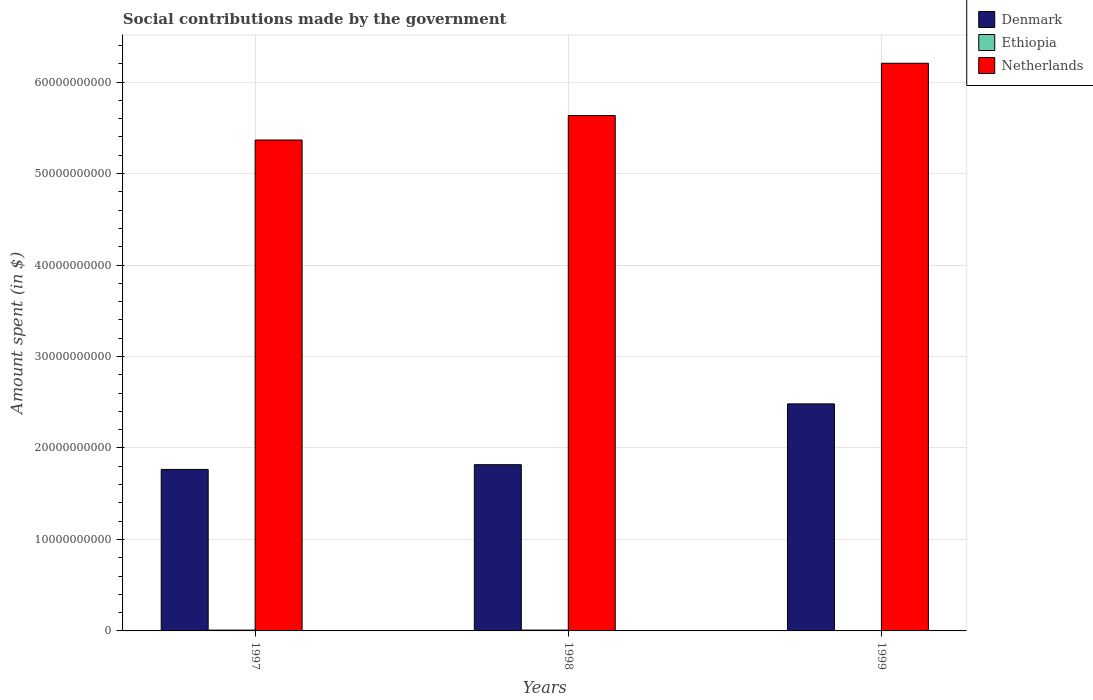How many different coloured bars are there?
Ensure brevity in your answer.  3. How many groups of bars are there?
Your answer should be very brief. 3. Are the number of bars per tick equal to the number of legend labels?
Your answer should be very brief. Yes. How many bars are there on the 1st tick from the right?
Your response must be concise. 3. In how many cases, is the number of bars for a given year not equal to the number of legend labels?
Offer a terse response. 0. What is the amount spent on social contributions in Denmark in 1999?
Provide a short and direct response. 2.48e+1. Across all years, what is the maximum amount spent on social contributions in Denmark?
Provide a short and direct response. 2.48e+1. Across all years, what is the minimum amount spent on social contributions in Ethiopia?
Offer a very short reply. 2.00e+05. In which year was the amount spent on social contributions in Ethiopia maximum?
Provide a short and direct response. 1998. In which year was the amount spent on social contributions in Netherlands minimum?
Provide a short and direct response. 1997. What is the total amount spent on social contributions in Ethiopia in the graph?
Give a very brief answer. 1.80e+08. What is the difference between the amount spent on social contributions in Ethiopia in 1997 and that in 1998?
Offer a terse response. -3.90e+06. What is the difference between the amount spent on social contributions in Ethiopia in 1998 and the amount spent on social contributions in Denmark in 1997?
Your response must be concise. -1.76e+1. What is the average amount spent on social contributions in Denmark per year?
Make the answer very short. 2.02e+1. In the year 1997, what is the difference between the amount spent on social contributions in Ethiopia and amount spent on social contributions in Denmark?
Offer a terse response. -1.76e+1. What is the ratio of the amount spent on social contributions in Ethiopia in 1998 to that in 1999?
Provide a short and direct response. 460.5. What is the difference between the highest and the second highest amount spent on social contributions in Ethiopia?
Offer a very short reply. 3.90e+06. What is the difference between the highest and the lowest amount spent on social contributions in Ethiopia?
Make the answer very short. 9.19e+07. Is the sum of the amount spent on social contributions in Denmark in 1997 and 1999 greater than the maximum amount spent on social contributions in Netherlands across all years?
Keep it short and to the point. No. What does the 2nd bar from the left in 1999 represents?
Your response must be concise. Ethiopia. Is it the case that in every year, the sum of the amount spent on social contributions in Denmark and amount spent on social contributions in Ethiopia is greater than the amount spent on social contributions in Netherlands?
Offer a terse response. No. How many bars are there?
Offer a terse response. 9. Are all the bars in the graph horizontal?
Keep it short and to the point. No. How many years are there in the graph?
Provide a succinct answer. 3. What is the difference between two consecutive major ticks on the Y-axis?
Ensure brevity in your answer.  1.00e+1. Does the graph contain any zero values?
Keep it short and to the point. No. Where does the legend appear in the graph?
Your response must be concise. Top right. How are the legend labels stacked?
Your answer should be compact. Vertical. What is the title of the graph?
Ensure brevity in your answer.  Social contributions made by the government. What is the label or title of the X-axis?
Provide a succinct answer. Years. What is the label or title of the Y-axis?
Provide a succinct answer. Amount spent (in $). What is the Amount spent (in $) in Denmark in 1997?
Provide a succinct answer. 1.77e+1. What is the Amount spent (in $) of Ethiopia in 1997?
Make the answer very short. 8.82e+07. What is the Amount spent (in $) in Netherlands in 1997?
Your answer should be very brief. 5.37e+1. What is the Amount spent (in $) of Denmark in 1998?
Offer a terse response. 1.82e+1. What is the Amount spent (in $) of Ethiopia in 1998?
Your response must be concise. 9.21e+07. What is the Amount spent (in $) of Netherlands in 1998?
Offer a terse response. 5.63e+1. What is the Amount spent (in $) of Denmark in 1999?
Your response must be concise. 2.48e+1. What is the Amount spent (in $) in Netherlands in 1999?
Keep it short and to the point. 6.21e+1. Across all years, what is the maximum Amount spent (in $) in Denmark?
Your response must be concise. 2.48e+1. Across all years, what is the maximum Amount spent (in $) in Ethiopia?
Your answer should be compact. 9.21e+07. Across all years, what is the maximum Amount spent (in $) in Netherlands?
Your response must be concise. 6.21e+1. Across all years, what is the minimum Amount spent (in $) of Denmark?
Your answer should be compact. 1.77e+1. Across all years, what is the minimum Amount spent (in $) of Netherlands?
Offer a terse response. 5.37e+1. What is the total Amount spent (in $) in Denmark in the graph?
Ensure brevity in your answer.  6.06e+1. What is the total Amount spent (in $) in Ethiopia in the graph?
Your answer should be very brief. 1.80e+08. What is the total Amount spent (in $) of Netherlands in the graph?
Provide a succinct answer. 1.72e+11. What is the difference between the Amount spent (in $) of Denmark in 1997 and that in 1998?
Your answer should be very brief. -5.17e+08. What is the difference between the Amount spent (in $) in Ethiopia in 1997 and that in 1998?
Your response must be concise. -3.90e+06. What is the difference between the Amount spent (in $) of Netherlands in 1997 and that in 1998?
Offer a very short reply. -2.68e+09. What is the difference between the Amount spent (in $) of Denmark in 1997 and that in 1999?
Your answer should be compact. -7.16e+09. What is the difference between the Amount spent (in $) of Ethiopia in 1997 and that in 1999?
Your answer should be very brief. 8.80e+07. What is the difference between the Amount spent (in $) in Netherlands in 1997 and that in 1999?
Ensure brevity in your answer.  -8.39e+09. What is the difference between the Amount spent (in $) in Denmark in 1998 and that in 1999?
Your answer should be very brief. -6.64e+09. What is the difference between the Amount spent (in $) of Ethiopia in 1998 and that in 1999?
Your response must be concise. 9.19e+07. What is the difference between the Amount spent (in $) of Netherlands in 1998 and that in 1999?
Offer a terse response. -5.72e+09. What is the difference between the Amount spent (in $) of Denmark in 1997 and the Amount spent (in $) of Ethiopia in 1998?
Your answer should be compact. 1.76e+1. What is the difference between the Amount spent (in $) of Denmark in 1997 and the Amount spent (in $) of Netherlands in 1998?
Offer a terse response. -3.87e+1. What is the difference between the Amount spent (in $) of Ethiopia in 1997 and the Amount spent (in $) of Netherlands in 1998?
Offer a very short reply. -5.63e+1. What is the difference between the Amount spent (in $) in Denmark in 1997 and the Amount spent (in $) in Ethiopia in 1999?
Give a very brief answer. 1.77e+1. What is the difference between the Amount spent (in $) in Denmark in 1997 and the Amount spent (in $) in Netherlands in 1999?
Your answer should be very brief. -4.44e+1. What is the difference between the Amount spent (in $) in Ethiopia in 1997 and the Amount spent (in $) in Netherlands in 1999?
Give a very brief answer. -6.20e+1. What is the difference between the Amount spent (in $) in Denmark in 1998 and the Amount spent (in $) in Ethiopia in 1999?
Offer a very short reply. 1.82e+1. What is the difference between the Amount spent (in $) of Denmark in 1998 and the Amount spent (in $) of Netherlands in 1999?
Provide a short and direct response. -4.39e+1. What is the difference between the Amount spent (in $) in Ethiopia in 1998 and the Amount spent (in $) in Netherlands in 1999?
Give a very brief answer. -6.20e+1. What is the average Amount spent (in $) in Denmark per year?
Ensure brevity in your answer.  2.02e+1. What is the average Amount spent (in $) in Ethiopia per year?
Your answer should be very brief. 6.02e+07. What is the average Amount spent (in $) of Netherlands per year?
Give a very brief answer. 5.74e+1. In the year 1997, what is the difference between the Amount spent (in $) in Denmark and Amount spent (in $) in Ethiopia?
Keep it short and to the point. 1.76e+1. In the year 1997, what is the difference between the Amount spent (in $) in Denmark and Amount spent (in $) in Netherlands?
Make the answer very short. -3.60e+1. In the year 1997, what is the difference between the Amount spent (in $) of Ethiopia and Amount spent (in $) of Netherlands?
Provide a succinct answer. -5.36e+1. In the year 1998, what is the difference between the Amount spent (in $) of Denmark and Amount spent (in $) of Ethiopia?
Your response must be concise. 1.81e+1. In the year 1998, what is the difference between the Amount spent (in $) of Denmark and Amount spent (in $) of Netherlands?
Offer a very short reply. -3.82e+1. In the year 1998, what is the difference between the Amount spent (in $) in Ethiopia and Amount spent (in $) in Netherlands?
Provide a succinct answer. -5.63e+1. In the year 1999, what is the difference between the Amount spent (in $) of Denmark and Amount spent (in $) of Ethiopia?
Keep it short and to the point. 2.48e+1. In the year 1999, what is the difference between the Amount spent (in $) in Denmark and Amount spent (in $) in Netherlands?
Your answer should be very brief. -3.72e+1. In the year 1999, what is the difference between the Amount spent (in $) in Ethiopia and Amount spent (in $) in Netherlands?
Your response must be concise. -6.21e+1. What is the ratio of the Amount spent (in $) of Denmark in 1997 to that in 1998?
Offer a very short reply. 0.97. What is the ratio of the Amount spent (in $) of Ethiopia in 1997 to that in 1998?
Provide a short and direct response. 0.96. What is the ratio of the Amount spent (in $) of Netherlands in 1997 to that in 1998?
Your answer should be compact. 0.95. What is the ratio of the Amount spent (in $) in Denmark in 1997 to that in 1999?
Ensure brevity in your answer.  0.71. What is the ratio of the Amount spent (in $) of Ethiopia in 1997 to that in 1999?
Provide a succinct answer. 441. What is the ratio of the Amount spent (in $) in Netherlands in 1997 to that in 1999?
Your response must be concise. 0.86. What is the ratio of the Amount spent (in $) of Denmark in 1998 to that in 1999?
Ensure brevity in your answer.  0.73. What is the ratio of the Amount spent (in $) of Ethiopia in 1998 to that in 1999?
Your answer should be compact. 460.5. What is the ratio of the Amount spent (in $) in Netherlands in 1998 to that in 1999?
Give a very brief answer. 0.91. What is the difference between the highest and the second highest Amount spent (in $) of Denmark?
Your answer should be compact. 6.64e+09. What is the difference between the highest and the second highest Amount spent (in $) in Ethiopia?
Offer a terse response. 3.90e+06. What is the difference between the highest and the second highest Amount spent (in $) of Netherlands?
Give a very brief answer. 5.72e+09. What is the difference between the highest and the lowest Amount spent (in $) of Denmark?
Offer a very short reply. 7.16e+09. What is the difference between the highest and the lowest Amount spent (in $) in Ethiopia?
Your answer should be compact. 9.19e+07. What is the difference between the highest and the lowest Amount spent (in $) in Netherlands?
Your answer should be compact. 8.39e+09. 